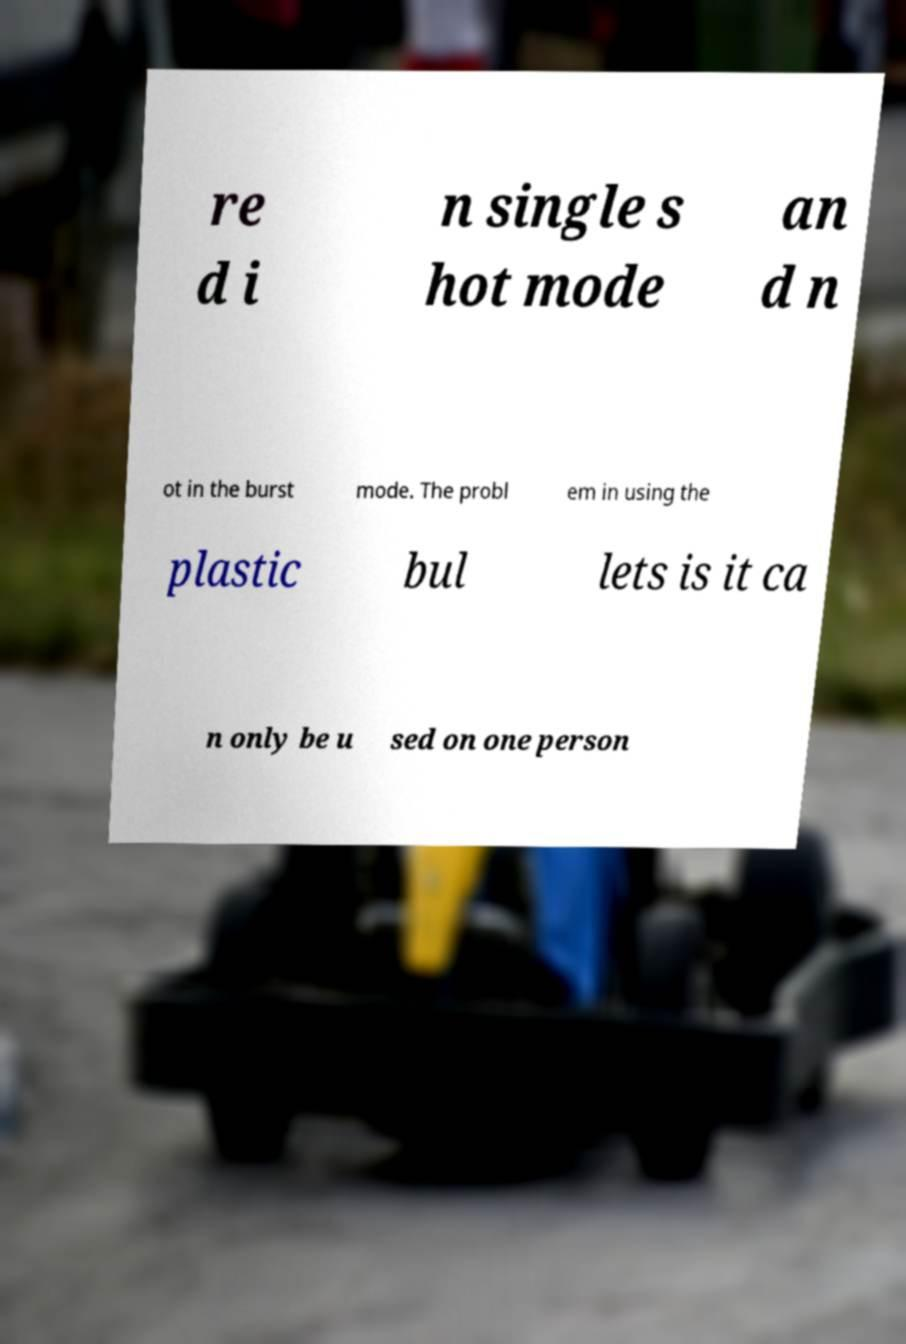Could you extract and type out the text from this image? re d i n single s hot mode an d n ot in the burst mode. The probl em in using the plastic bul lets is it ca n only be u sed on one person 